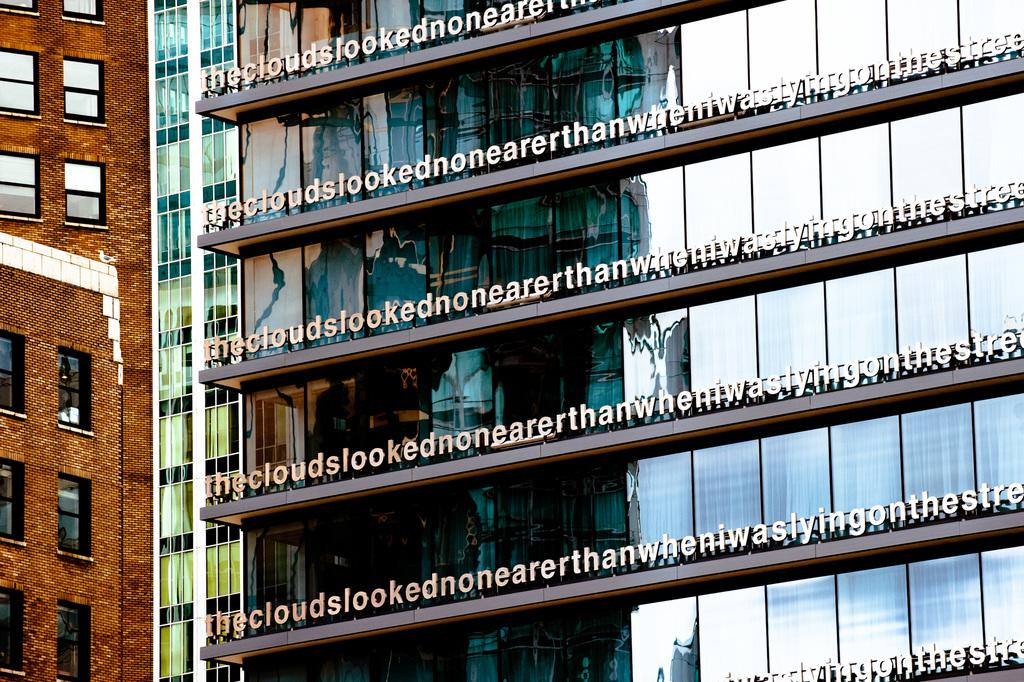What type of structures are visible in the image? There are buildings in the image. What architectural features can be seen on the buildings? There are windows visible on the buildings. What other objects are present in the image? There are boards in the image. Can you determine the time of day the image was taken? The image was likely taken during the day, as there is sufficient light to see the buildings and windows clearly. How does the money react to the poison in the image? There is no money or poison present in the image; it only features buildings, windows, and boards. 